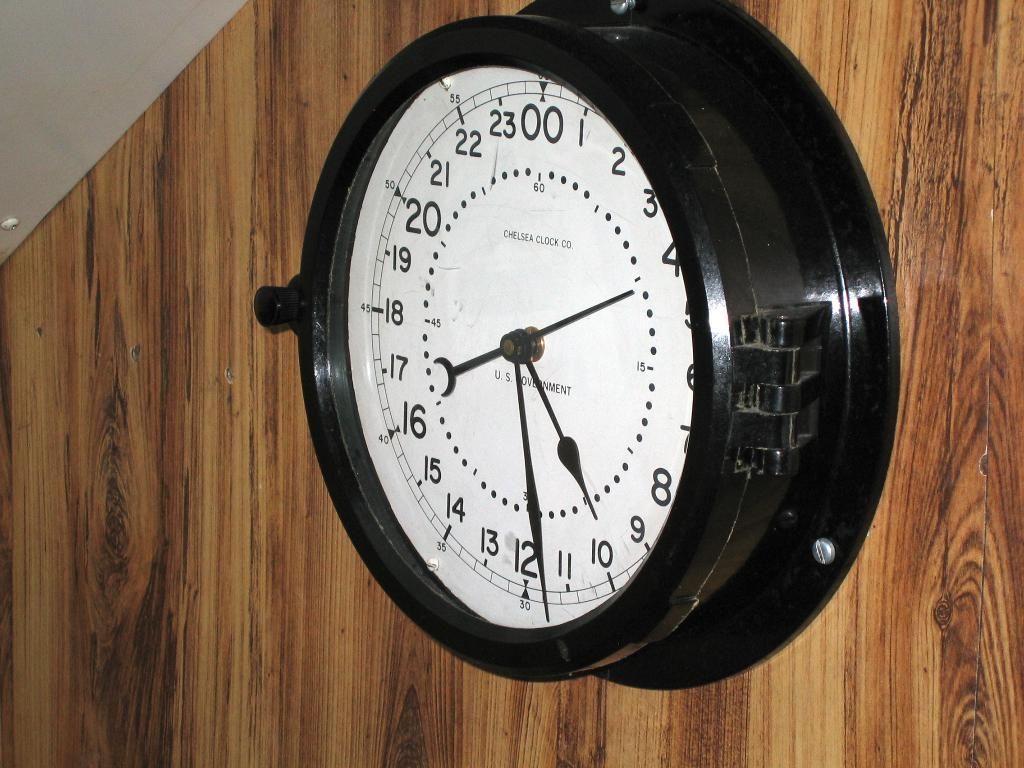<image>
Relay a brief, clear account of the picture shown. A black a white clock mounted on wood paneling from Chelsea Clock co. 